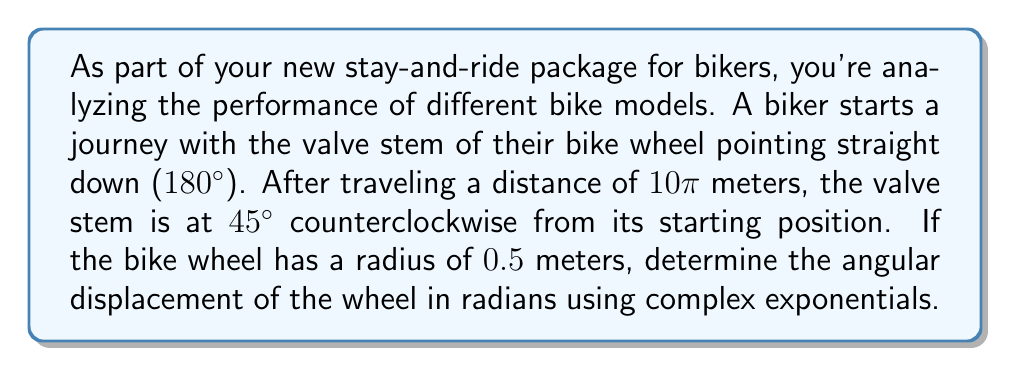Show me your answer to this math problem. Let's approach this step-by-step using complex exponentials:

1) First, we need to calculate the total rotation of the wheel. The distance traveled is 10π meters, and the wheel radius is 0.5 meters.

   Total rotation = Distance / Circumference
   $$ \text{Total rotation} = \frac{10\pi}{2\pi r} = \frac{10\pi}{2\pi(0.5)} = 10 \text{ rotations} $$

2) Now, we need to convert this to radians:
   $$ 10 \text{ rotations} = 10 \cdot 2\pi = 20\pi \text{ radians} $$

3) We can represent the initial position of the valve stem as a complex number:
   $$ z_1 = e^{i\pi} = -1 $$

4) The final position can be represented as:
   $$ z_2 = e^{i(\pi/4)} = \frac{1}{\sqrt{2}}(1+i) $$

5) The relationship between these two positions can be expressed as:
   $$ z_2 = z_1 \cdot e^{i\theta} $$
   where θ is the angular displacement we're looking for.

6) Substituting the values:
   $$ \frac{1}{\sqrt{2}}(1+i) = -1 \cdot e^{i\theta} $$

7) Solving for θ:
   $$ e^{i\theta} = -\frac{1}{\sqrt{2}}(1+i) $$
   $$ \theta = \arg(-\frac{1}{\sqrt{2}}(1+i)) + 20\pi $$
   $$ \theta = \frac{5\pi}{4} + 20\pi = \frac{85\pi}{4} \text{ radians} $$

The additional 20π comes from the full rotations calculated in step 2.
Answer: The angular displacement of the wheel is $\frac{85\pi}{4}$ radians. 